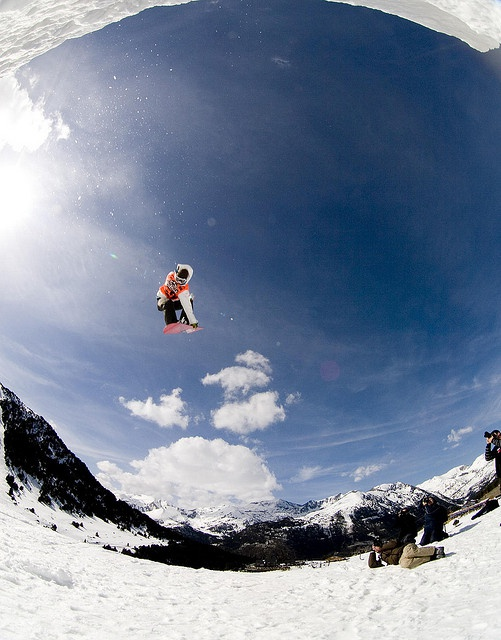Describe the objects in this image and their specific colors. I can see people in lightgray, black, darkgray, and gray tones, people in lightgray, black, gray, and tan tones, people in lightgray, black, gray, darkgray, and white tones, people in lightgray, black, gray, and darkgray tones, and snowboard in lightgray, darkgray, brown, gray, and lightpink tones in this image. 